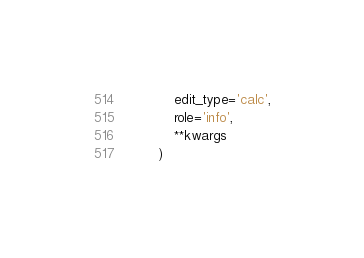<code> <loc_0><loc_0><loc_500><loc_500><_Python_>            edit_type='calc',
            role='info',
            **kwargs
        )
</code> 